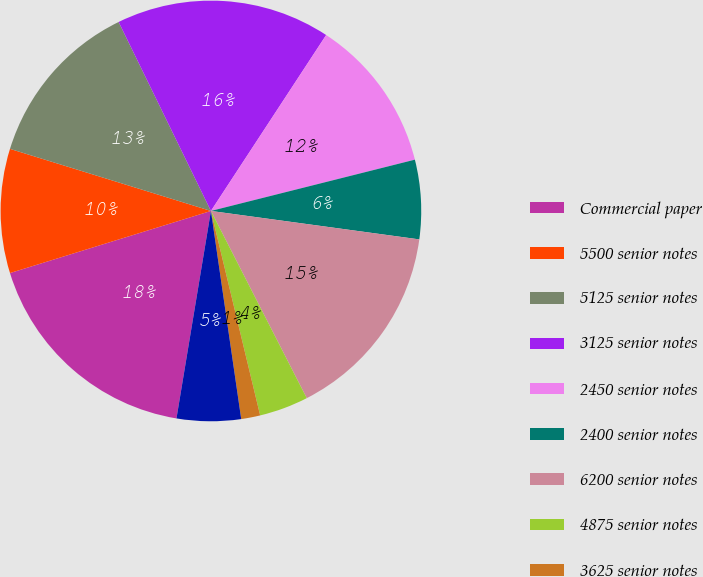<chart> <loc_0><loc_0><loc_500><loc_500><pie_chart><fcel>Commercial paper<fcel>5500 senior notes<fcel>5125 senior notes<fcel>3125 senior notes<fcel>2450 senior notes<fcel>2400 senior notes<fcel>6200 senior notes<fcel>4875 senior notes<fcel>3625 senior notes<fcel>3400 senior notes<nl><fcel>17.61%<fcel>9.54%<fcel>13.0%<fcel>16.46%<fcel>11.85%<fcel>6.08%<fcel>15.31%<fcel>3.77%<fcel>1.46%<fcel>4.92%<nl></chart> 